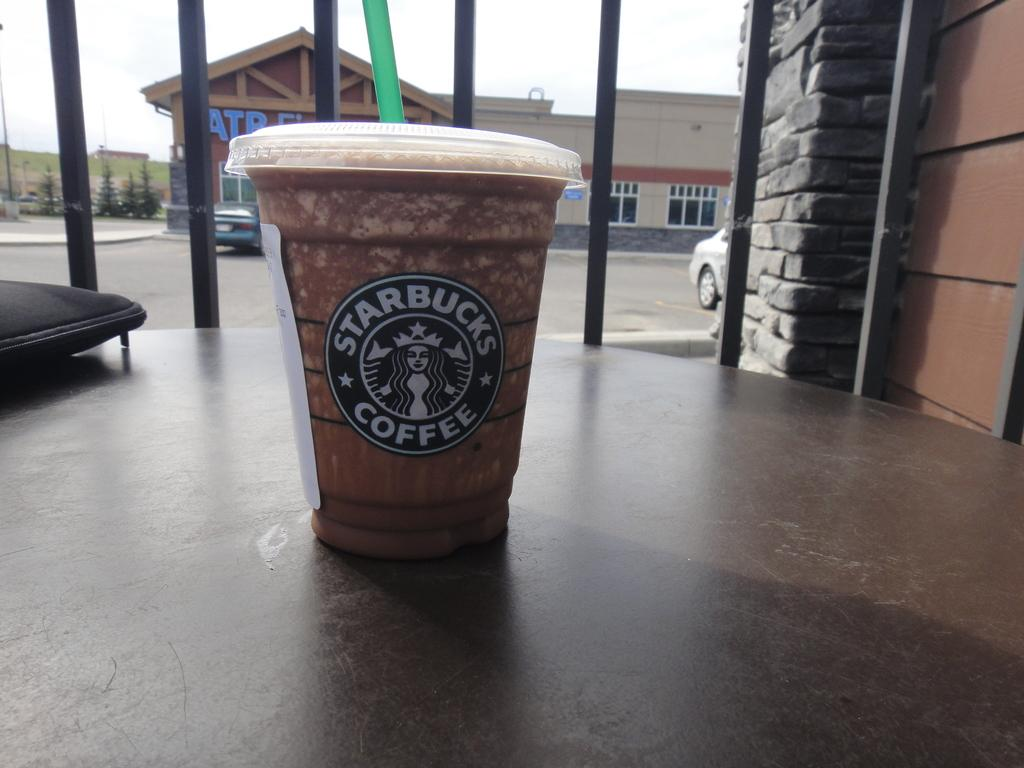What is in the glass that is visible in the image? There is a cap and straw in the glass in the image. Where is the glass located in the image? The glass is on the floor in the image. What can be seen on the glass? There is a label on the glass. What can be seen in the background of the image? There are iron rods, buildings, windows, vehicles, trees, and the sky visible in the background of the image. What type of bat is hanging from the neck of the person in the image? There is no person or bat present in the image. How is the lock attached to the glass in the image? There is no lock present on the glass in the image. 